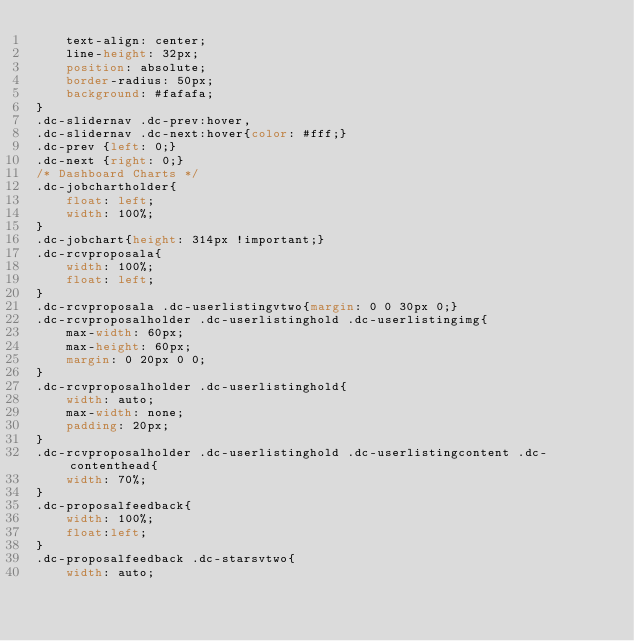<code> <loc_0><loc_0><loc_500><loc_500><_CSS_>	text-align: center;
	line-height: 32px;
	position: absolute;
	border-radius: 50px;
	background: #fafafa;
}
.dc-slidernav .dc-prev:hover,
.dc-slidernav .dc-next:hover{color: #fff;}
.dc-prev {left: 0;}
.dc-next {right: 0;}
/* Dashboard Charts */
.dc-jobchartholder{
	float: left;
	width: 100%;
}
.dc-jobchart{height: 314px !important;}
.dc-rcvproposala{
	width: 100%;
	float: left;
}
.dc-rcvproposala .dc-userlistingvtwo{margin: 0 0 30px 0;}
.dc-rcvproposalholder .dc-userlistinghold .dc-userlistingimg{
	max-width: 60px;
	max-height: 60px;
	margin: 0 20px 0 0;
}
.dc-rcvproposalholder .dc-userlistinghold{
	width: auto;
	max-width: none;
	padding: 20px;
}
.dc-rcvproposalholder .dc-userlistinghold .dc-userlistingcontent .dc-contenthead{
	width: 70%;
}
.dc-proposalfeedback{
	width: 100%;
	float:left;
}
.dc-proposalfeedback .dc-starsvtwo{
	width: auto;</code> 